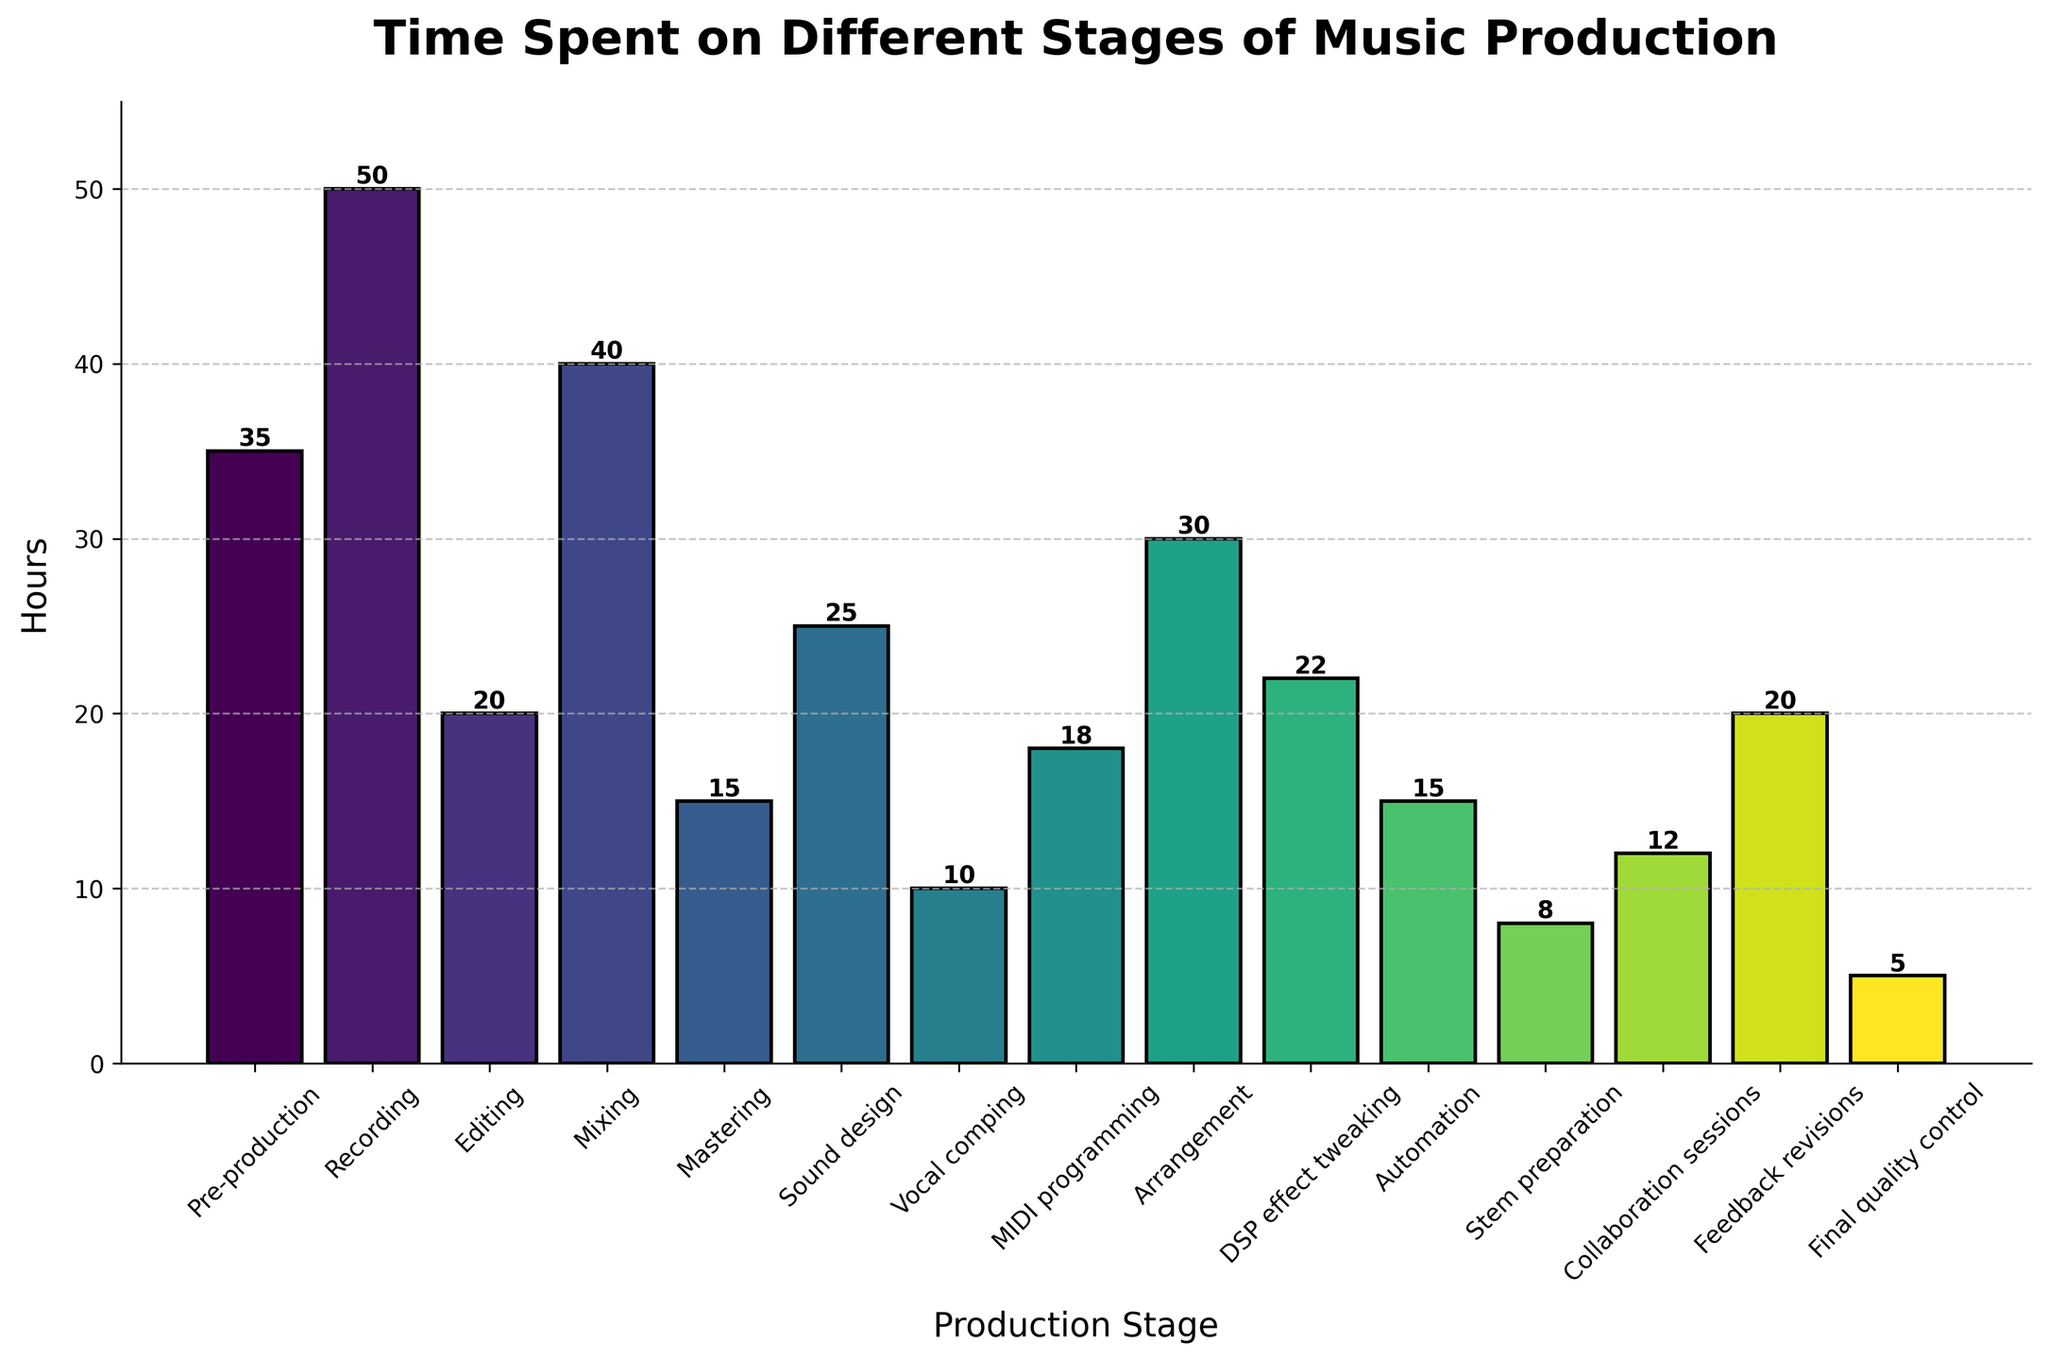Which stage has the highest amount of time spent? Look at the bar that reaches the highest on the vertical axis. The highest bar represents the stage with the most hours spent.
Answer: Recording Which stage has the lowest amount of time spent? Look at the bar that is the shortest on the vertical axis. The lowest bar represents the stage with the least hours spent.
Answer: Final quality control How much more time is spent on Recording than Mixing? Find the height of the bars for Recording and Mixing and subtract the height of the Mixing bar from the height of the Recording bar. Recording is 50 hours, and Mixing is 40 hours. 50 - 40 = 10 hours more.
Answer: 10 hours What is the total time spent on Editing, Mixing, and Mastering combined? Sum the heights of the bars for Editing, Mixing, and Mastering. Editing: 20 hours, Mixing: 40 hours, Mastering: 15 hours. 20 + 40 + 15 = 75 hours.
Answer: 75 hours What stage forms the midpoint value in terms of hours spent when all stages are arranged in ascending order? First, arrange the stages' hours in ascending order: 5, 8, 10, 12, 15, 15, 18, 20, 20, 22, 25, 30, 35, 40, 50. The midpoint (median) value in this sorted list is 20 hours, corresponding to Editing and Feedback revisions.
Answer: Editing and Feedback revisions How many stages have more than 20 hours spent on them? Count the number of bars that extend above the 20-hour mark on the vertical axis.
Answer: 6 stages What is the difference in time spent between the most and least time-consuming stages? Subtract the height of the shortest bar from the height of the tallest bar. Recording is 50 hours, and Final quality control is 5 hours. 50 - 5 = 45 hours.
Answer: 45 hours Which stages have the same amount of time spent on them? Examine the bars that reach the same height. Mastering and Automation both reach 15 hours, and Editing and Feedback revisions both reach 20 hours.
Answer: Mastering and Automation, Editing and Feedback revisions What percentage of the total hours is spent on Pre-production? First, sum all the hours spent on all stages. Total hours = 35+50+20+40+15+25+10+18+30+22+15+8+12+20+5 = 325 hours. Then, calculate the percentage: (35 / 325) * 100 ≈ 10.77%.
Answer: Approximately 10.77% Which stage has a visually recognizable color gradient starting from the bottom to the top? Inspect the color gradients used for the bars. The figure uses a colorful gradient pattern, meaning each consecutive bar might have a different shade but maintain a sequential color pattern. Each bar gradually changes from one shade to another.
Answer: Observed throughout the chart What is the sum of all hours spent on stages that are related to editing or modifying audio in some way? Identify the stages that involve editing or modifying audio: Editing (20 hours), Mixing (40 hours), Mastering (15 hours), Sound design (25 hours), Vocal comping (10 hours), MIDI programming (18 hours), Arrangement (30 hours), DSP effect tweaking (22 hours), Automation (15 hours), Stem preparation (8 hours), Feedback revisions (20 hours), Final quality control (5 hours). Sum these values: 20 + 40 + 15 + 25 + 10 + 18 + 30 + 22 + 15 + 8 + 20 + 5 = 228 hours.
Answer: 228 hours 